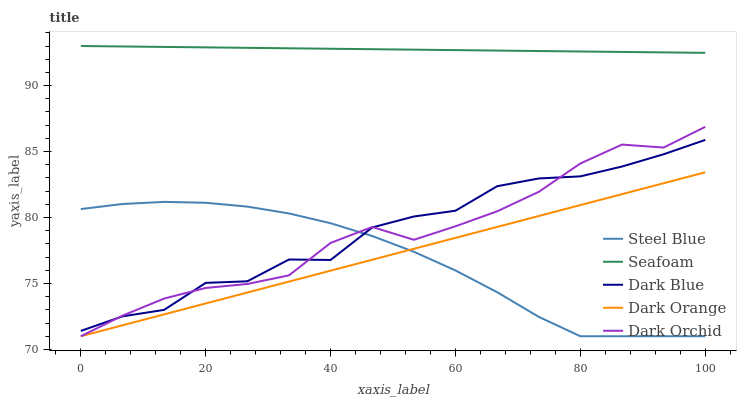Does Steel Blue have the minimum area under the curve?
Answer yes or no. Yes. Does Seafoam have the maximum area under the curve?
Answer yes or no. Yes. Does Dark Blue have the minimum area under the curve?
Answer yes or no. No. Does Dark Blue have the maximum area under the curve?
Answer yes or no. No. Is Dark Orange the smoothest?
Answer yes or no. Yes. Is Dark Blue the roughest?
Answer yes or no. Yes. Is Steel Blue the smoothest?
Answer yes or no. No. Is Steel Blue the roughest?
Answer yes or no. No. Does Dark Orange have the lowest value?
Answer yes or no. Yes. Does Dark Blue have the lowest value?
Answer yes or no. No. Does Seafoam have the highest value?
Answer yes or no. Yes. Does Dark Blue have the highest value?
Answer yes or no. No. Is Steel Blue less than Seafoam?
Answer yes or no. Yes. Is Seafoam greater than Dark Blue?
Answer yes or no. Yes. Does Dark Orchid intersect Steel Blue?
Answer yes or no. Yes. Is Dark Orchid less than Steel Blue?
Answer yes or no. No. Is Dark Orchid greater than Steel Blue?
Answer yes or no. No. Does Steel Blue intersect Seafoam?
Answer yes or no. No. 